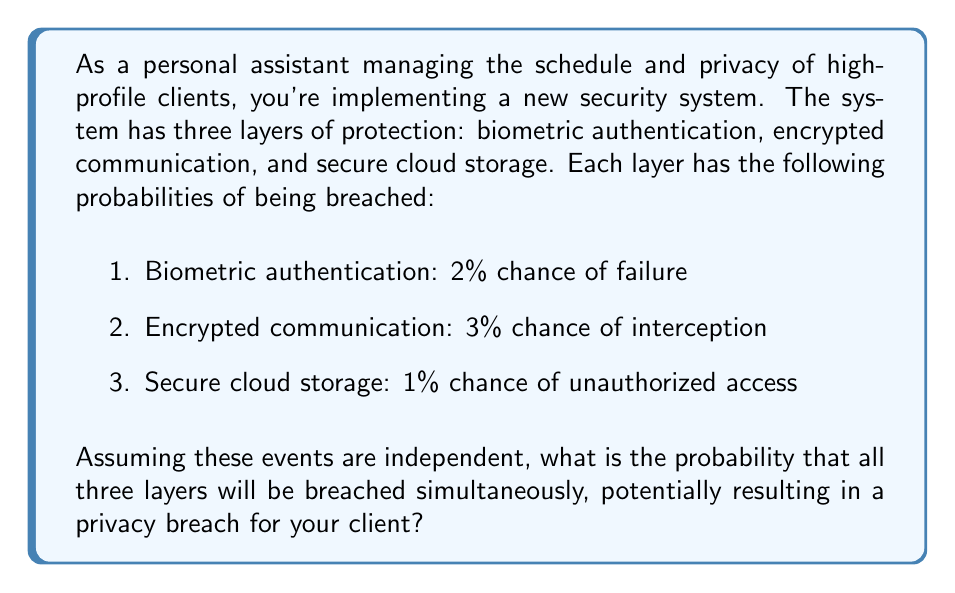Give your solution to this math problem. To solve this problem, we need to use the concept of independent events in probability theory. When events are independent, the probability of all of them occurring simultaneously is the product of their individual probabilities.

Let's define our events:
A: Biometric authentication is breached
B: Encrypted communication is intercepted
C: Secure cloud storage is accessed without authorization

Given probabilities:
P(A) = 0.02
P(B) = 0.03
P(C) = 0.01

Since these events are independent, the probability of all three occurring simultaneously is:

$$P(A \cap B \cap C) = P(A) \times P(B) \times P(C)$$

Substituting the values:

$$P(A \cap B \cap C) = 0.02 \times 0.03 \times 0.01$$

Calculating:

$$P(A \cap B \cap C) = 0.000006$$

This can also be expressed as $6 \times 10^{-6}$ or 0.0006%.
Answer: The probability of all three security layers being breached simultaneously is 0.000006 or 0.0006%. 